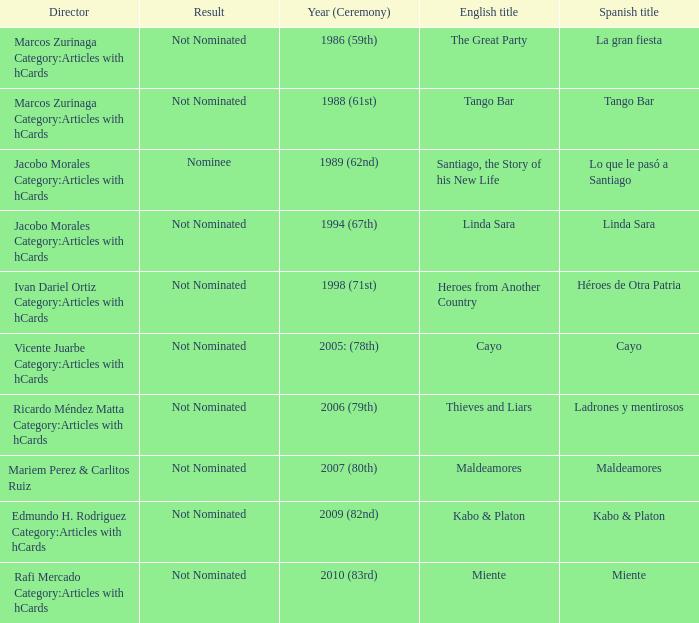What was the English title of Ladrones Y Mentirosos? Thieves and Liars. 